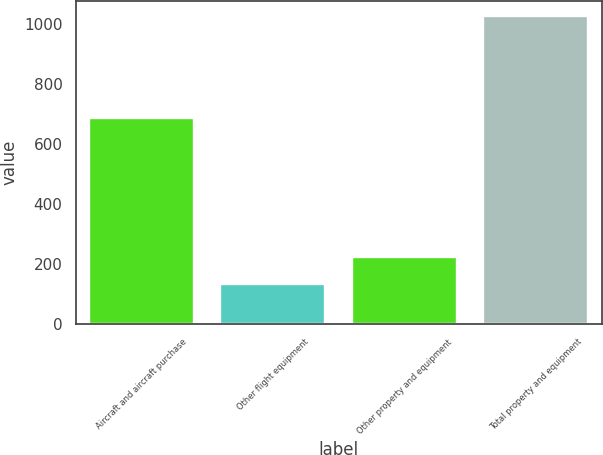Convert chart. <chart><loc_0><loc_0><loc_500><loc_500><bar_chart><fcel>Aircraft and aircraft purchase<fcel>Other flight equipment<fcel>Other property and equipment<fcel>Total property and equipment<nl><fcel>685<fcel>135<fcel>224<fcel>1025<nl></chart> 